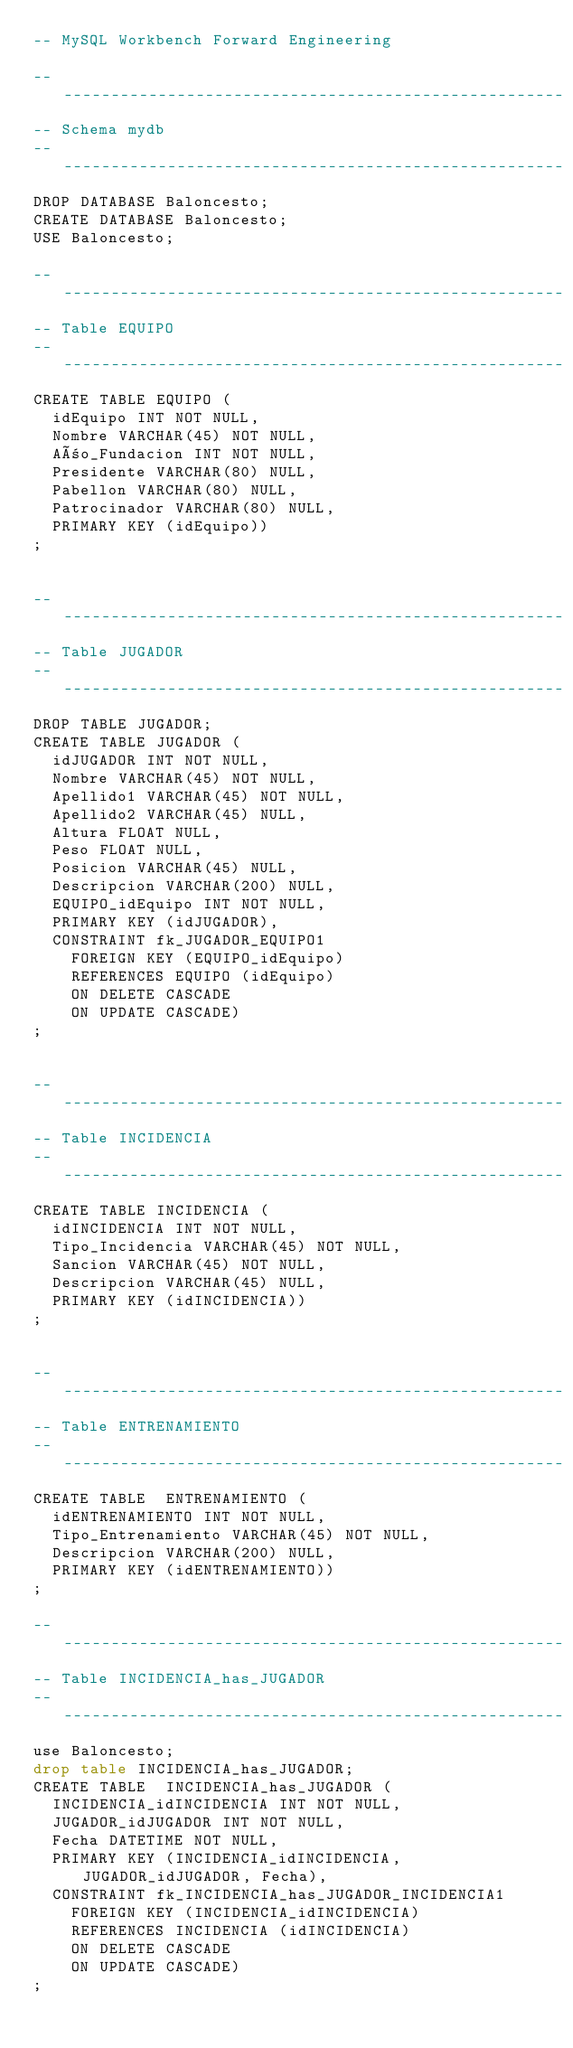Convert code to text. <code><loc_0><loc_0><loc_500><loc_500><_SQL_>-- MySQL Workbench Forward Engineering

-- -----------------------------------------------------
-- Schema mydb
-- -----------------------------------------------------
DROP DATABASE Baloncesto;
CREATE DATABASE Baloncesto;
USE Baloncesto;

-- -----------------------------------------------------
-- Table EQUIPO
-- -----------------------------------------------------
CREATE TABLE EQUIPO (
  idEquipo INT NOT NULL,
  Nombre VARCHAR(45) NOT NULL,
  Año_Fundacion INT NOT NULL,
  Presidente VARCHAR(80) NULL,
  Pabellon VARCHAR(80) NULL,
  Patrocinador VARCHAR(80) NULL,
  PRIMARY KEY (idEquipo))
;


-- -----------------------------------------------------
-- Table JUGADOR
-- -----------------------------------------------------
DROP TABLE JUGADOR;
CREATE TABLE JUGADOR (
  idJUGADOR INT NOT NULL,
  Nombre VARCHAR(45) NOT NULL,
  Apellido1 VARCHAR(45) NOT NULL,
  Apellido2 VARCHAR(45) NULL,
  Altura FLOAT NULL,
  Peso FLOAT NULL,
  Posicion VARCHAR(45) NULL,
  Descripcion VARCHAR(200) NULL,
  EQUIPO_idEquipo INT NOT NULL,
  PRIMARY KEY (idJUGADOR),
  CONSTRAINT fk_JUGADOR_EQUIPO1
    FOREIGN KEY (EQUIPO_idEquipo)
    REFERENCES EQUIPO (idEquipo)
    ON DELETE CASCADE
    ON UPDATE CASCADE)
;


-- -----------------------------------------------------
-- Table INCIDENCIA
-- -----------------------------------------------------
CREATE TABLE INCIDENCIA (
  idINCIDENCIA INT NOT NULL,
  Tipo_Incidencia VARCHAR(45) NOT NULL,
  Sancion VARCHAR(45) NOT NULL,
  Descripcion VARCHAR(45) NULL,
  PRIMARY KEY (idINCIDENCIA))
;


-- -----------------------------------------------------
-- Table ENTRENAMIENTO
-- -----------------------------------------------------
CREATE TABLE  ENTRENAMIENTO (
  idENTRENAMIENTO INT NOT NULL,
  Tipo_Entrenamiento VARCHAR(45) NOT NULL,
  Descripcion VARCHAR(200) NULL,
  PRIMARY KEY (idENTRENAMIENTO))
;

-- -----------------------------------------------------
-- Table INCIDENCIA_has_JUGADOR
-- -----------------------------------------------------
use Baloncesto;
drop table INCIDENCIA_has_JUGADOR;
CREATE TABLE  INCIDENCIA_has_JUGADOR (
  INCIDENCIA_idINCIDENCIA INT NOT NULL,
  JUGADOR_idJUGADOR INT NOT NULL,
  Fecha DATETIME NOT NULL,
  PRIMARY KEY (INCIDENCIA_idINCIDENCIA, JUGADOR_idJUGADOR, Fecha),
  CONSTRAINT fk_INCIDENCIA_has_JUGADOR_INCIDENCIA1
    FOREIGN KEY (INCIDENCIA_idINCIDENCIA)
    REFERENCES INCIDENCIA (idINCIDENCIA)
    ON DELETE CASCADE
    ON UPDATE CASCADE)
;</code> 